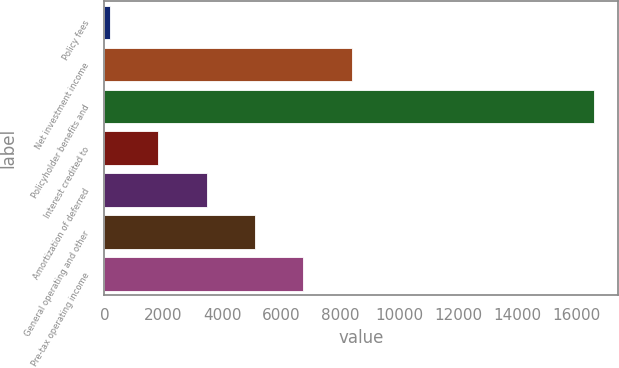Convert chart to OTSL. <chart><loc_0><loc_0><loc_500><loc_500><bar_chart><fcel>Policy fees<fcel>Net investment income<fcel>Policyholder benefits and<fcel>Interest credited to<fcel>Amortization of deferred<fcel>General operating and other<fcel>Pre-tax operating income<nl><fcel>187<fcel>8381<fcel>16575<fcel>1825.8<fcel>3464.6<fcel>5103.4<fcel>6742.2<nl></chart> 